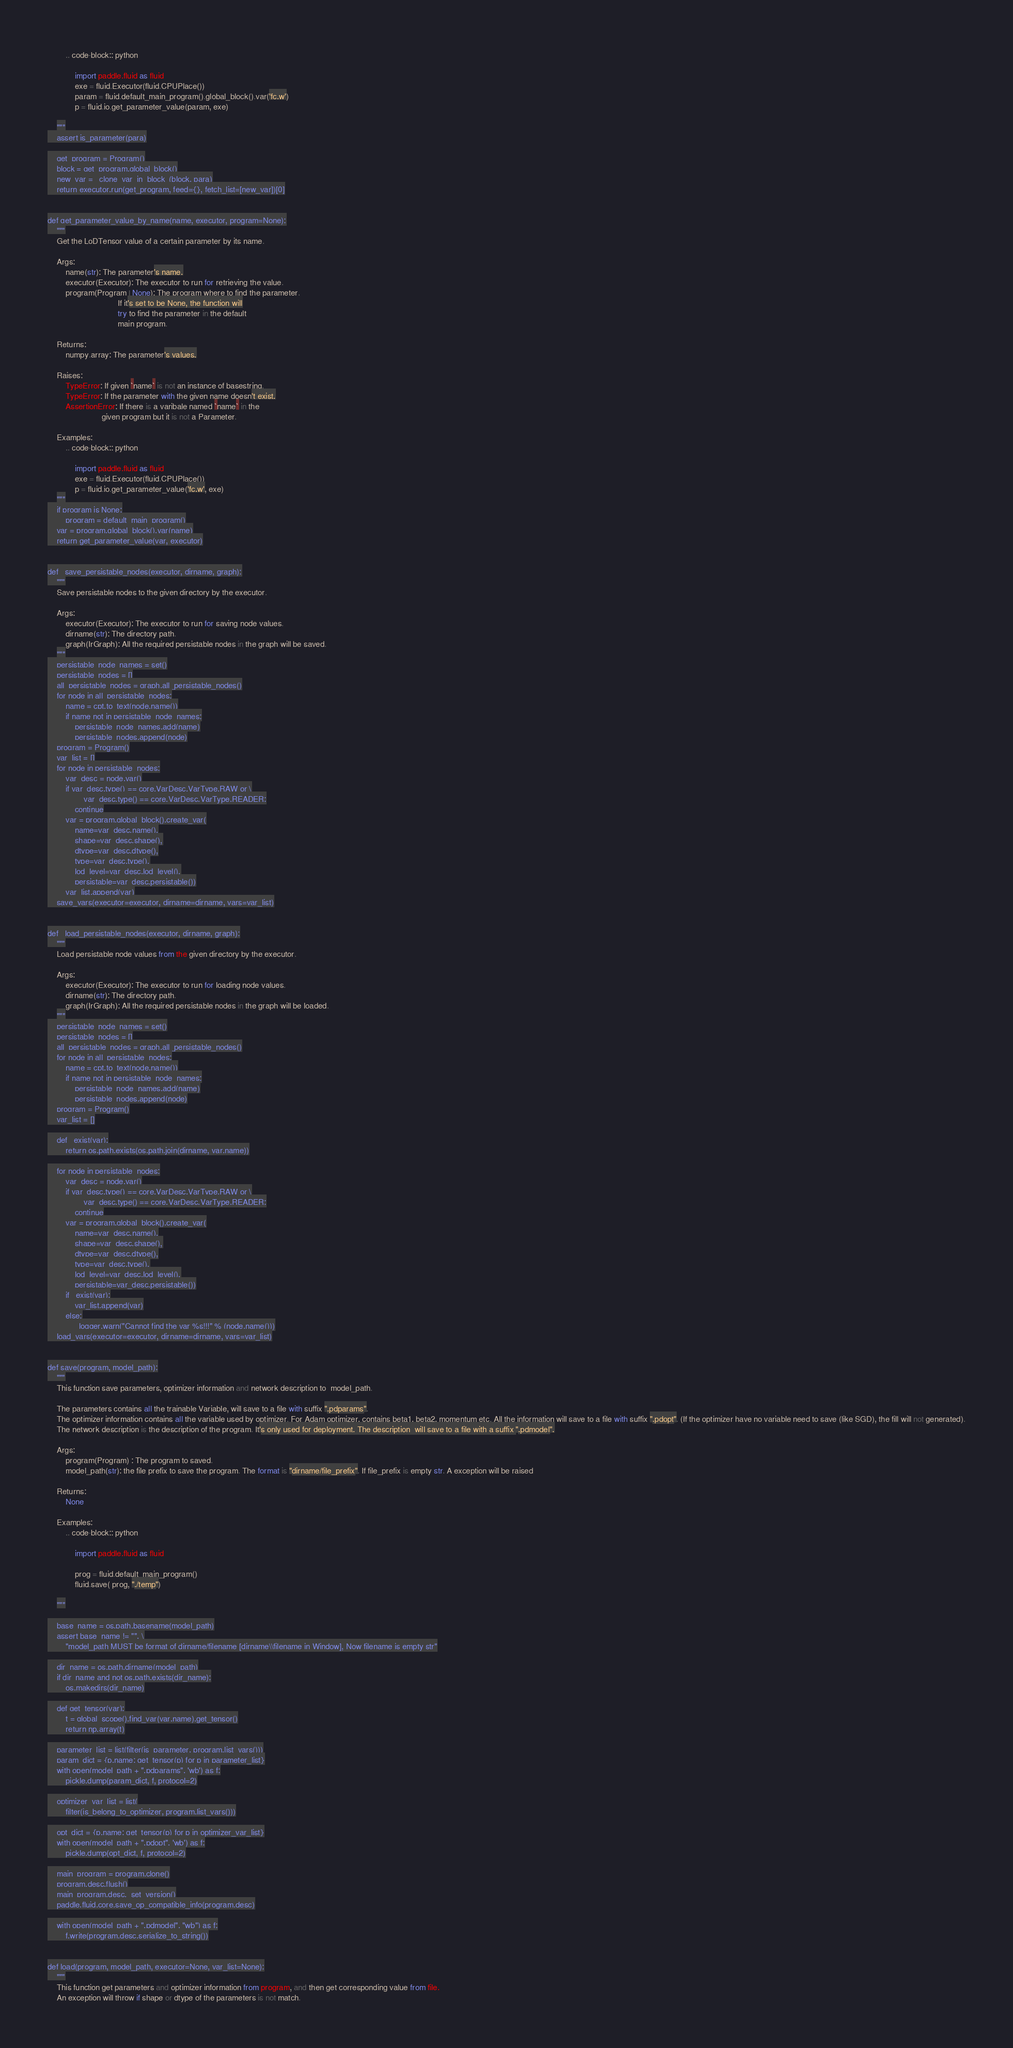Convert code to text. <code><loc_0><loc_0><loc_500><loc_500><_Python_>        .. code-block:: python

            import paddle.fluid as fluid
            exe = fluid.Executor(fluid.CPUPlace())
            param = fluid.default_main_program().global_block().var('fc.w')
            p = fluid.io.get_parameter_value(param, exe)

    """
    assert is_parameter(para)

    get_program = Program()
    block = get_program.global_block()
    new_var = _clone_var_in_block_(block, para)
    return executor.run(get_program, feed={}, fetch_list=[new_var])[0]


def get_parameter_value_by_name(name, executor, program=None):
    """
    Get the LoDTensor value of a certain parameter by its name.

    Args:
        name(str): The parameter's name.
        executor(Executor): The executor to run for retrieving the value.
        program(Program | None): The program where to find the parameter.
                               If it's set to be None, the function will
                               try to find the parameter in the default
                               main program.

    Returns:
        numpy.array: The parameter's values.

    Raises:
        TypeError: If given `name` is not an instance of basestring.
        TypeError: If the parameter with the given name doesn't exist.
        AssertionError: If there is a varibale named `name` in the
                        given program but it is not a Parameter.

    Examples:
        .. code-block:: python

            import paddle.fluid as fluid
            exe = fluid.Executor(fluid.CPUPlace())
            p = fluid.io.get_parameter_value('fc.w', exe)
    """
    if program is None:
        program = default_main_program()
    var = program.global_block().var(name)
    return get_parameter_value(var, executor)


def _save_persistable_nodes(executor, dirname, graph):
    """
    Save persistable nodes to the given directory by the executor.

    Args:
        executor(Executor): The executor to run for saving node values.
        dirname(str): The directory path.
        graph(IrGraph): All the required persistable nodes in the graph will be saved.
    """
    persistable_node_names = set()
    persistable_nodes = []
    all_persistable_nodes = graph.all_persistable_nodes()
    for node in all_persistable_nodes:
        name = cpt.to_text(node.name())
        if name not in persistable_node_names:
            persistable_node_names.add(name)
            persistable_nodes.append(node)
    program = Program()
    var_list = []
    for node in persistable_nodes:
        var_desc = node.var()
        if var_desc.type() == core.VarDesc.VarType.RAW or \
                var_desc.type() == core.VarDesc.VarType.READER:
            continue
        var = program.global_block().create_var(
            name=var_desc.name(),
            shape=var_desc.shape(),
            dtype=var_desc.dtype(),
            type=var_desc.type(),
            lod_level=var_desc.lod_level(),
            persistable=var_desc.persistable())
        var_list.append(var)
    save_vars(executor=executor, dirname=dirname, vars=var_list)


def _load_persistable_nodes(executor, dirname, graph):
    """
    Load persistable node values from the given directory by the executor.

    Args:
        executor(Executor): The executor to run for loading node values.
        dirname(str): The directory path.
        graph(IrGraph): All the required persistable nodes in the graph will be loaded.
    """
    persistable_node_names = set()
    persistable_nodes = []
    all_persistable_nodes = graph.all_persistable_nodes()
    for node in all_persistable_nodes:
        name = cpt.to_text(node.name())
        if name not in persistable_node_names:
            persistable_node_names.add(name)
            persistable_nodes.append(node)
    program = Program()
    var_list = []

    def _exist(var):
        return os.path.exists(os.path.join(dirname, var.name))

    for node in persistable_nodes:
        var_desc = node.var()
        if var_desc.type() == core.VarDesc.VarType.RAW or \
                var_desc.type() == core.VarDesc.VarType.READER:
            continue
        var = program.global_block().create_var(
            name=var_desc.name(),
            shape=var_desc.shape(),
            dtype=var_desc.dtype(),
            type=var_desc.type(),
            lod_level=var_desc.lod_level(),
            persistable=var_desc.persistable())
        if _exist(var):
            var_list.append(var)
        else:
            _logger.warn("Cannot find the var %s!!!" % (node.name()))
    load_vars(executor=executor, dirname=dirname, vars=var_list)


def save(program, model_path):
    """
    This function save parameters, optimizer information and network description to  model_path.

    The parameters contains all the trainable Variable, will save to a file with suffix ".pdparams".
    The optimizer information contains all the variable used by optimizer. For Adam optimizer, contains beta1, beta2, momentum etc. All the information will save to a file with suffix ".pdopt". (If the optimizer have no variable need to save (like SGD), the fill will not generated).
    The network description is the description of the program. It's only used for deployment. The description  will save to a file with a suffix ".pdmodel".
    
    Args:
        program(Program) : The program to saved.
        model_path(str): the file prefix to save the program. The format is "dirname/file_prefix". If file_prefix is empty str. A exception will be raised

    Returns:
        None

    Examples:
        .. code-block:: python

            import paddle.fluid as fluid

            prog = fluid.default_main_program()
            fluid.save( prog, "./temp")

    """

    base_name = os.path.basename(model_path)
    assert base_name != "", \
        "model_path MUST be format of dirname/filename [dirname\\filename in Window], Now filename is empty str"

    dir_name = os.path.dirname(model_path)
    if dir_name and not os.path.exists(dir_name):
        os.makedirs(dir_name)

    def get_tensor(var):
        t = global_scope().find_var(var.name).get_tensor()
        return np.array(t)

    parameter_list = list(filter(is_parameter, program.list_vars()))
    param_dict = {p.name: get_tensor(p) for p in parameter_list}
    with open(model_path + ".pdparams", 'wb') as f:
        pickle.dump(param_dict, f, protocol=2)

    optimizer_var_list = list(
        filter(is_belong_to_optimizer, program.list_vars()))

    opt_dict = {p.name: get_tensor(p) for p in optimizer_var_list}
    with open(model_path + ".pdopt", 'wb') as f:
        pickle.dump(opt_dict, f, protocol=2)

    main_program = program.clone()
    program.desc.flush()
    main_program.desc._set_version()
    paddle.fluid.core.save_op_compatible_info(program.desc)

    with open(model_path + ".pdmodel", "wb") as f:
        f.write(program.desc.serialize_to_string())


def load(program, model_path, executor=None, var_list=None):
    """
    This function get parameters and optimizer information from program, and then get corresponding value from file.
    An exception will throw if shape or dtype of the parameters is not match.
</code> 